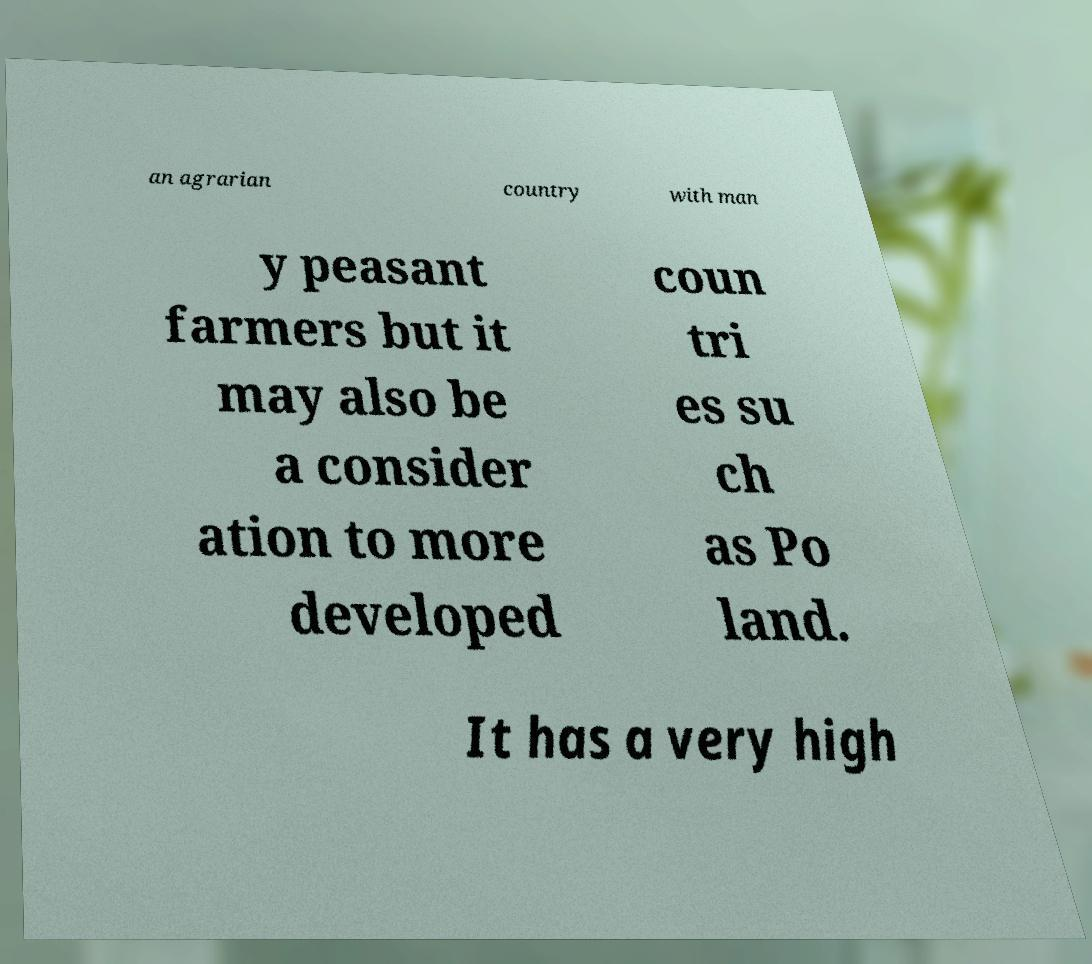Can you accurately transcribe the text from the provided image for me? an agrarian country with man y peasant farmers but it may also be a consider ation to more developed coun tri es su ch as Po land. It has a very high 